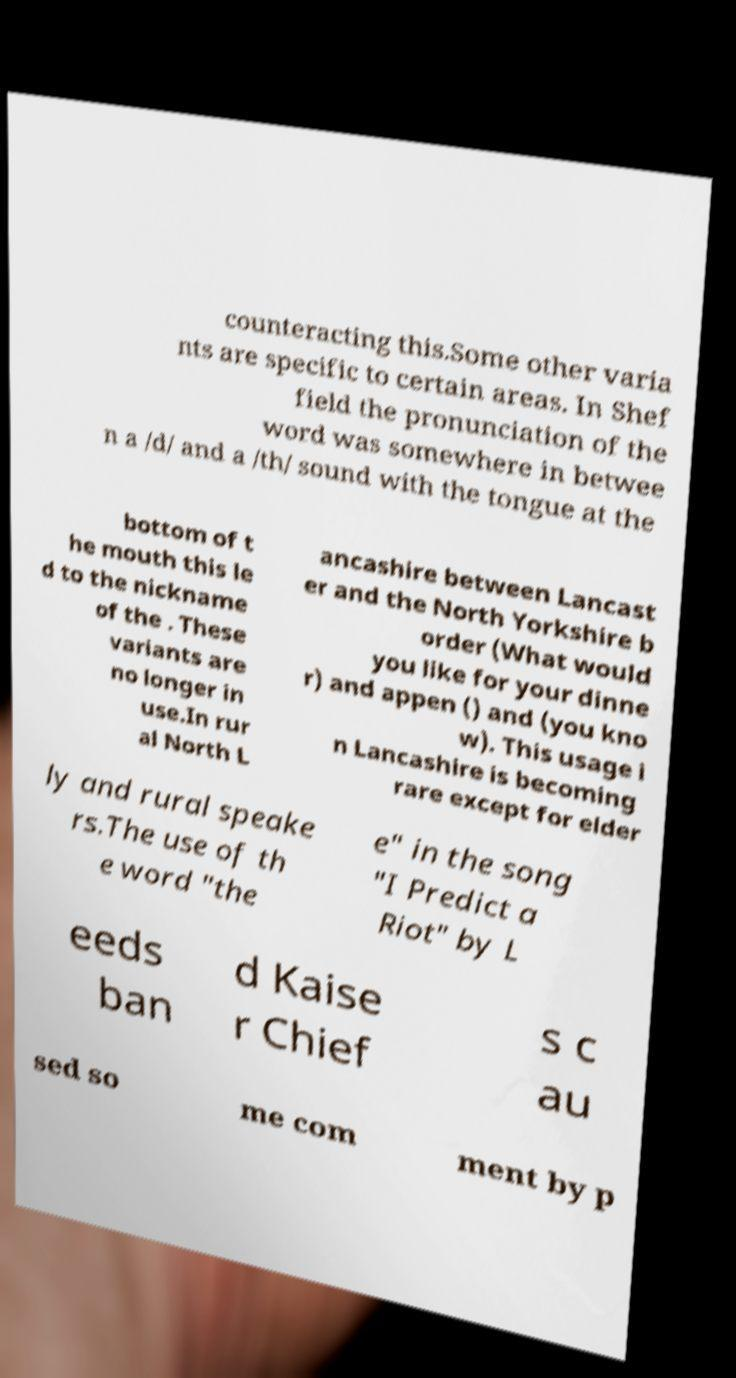For documentation purposes, I need the text within this image transcribed. Could you provide that? counteracting this.Some other varia nts are specific to certain areas. In Shef field the pronunciation of the word was somewhere in betwee n a /d/ and a /th/ sound with the tongue at the bottom of t he mouth this le d to the nickname of the . These variants are no longer in use.In rur al North L ancashire between Lancast er and the North Yorkshire b order (What would you like for your dinne r) and appen () and (you kno w). This usage i n Lancashire is becoming rare except for elder ly and rural speake rs.The use of th e word "the e" in the song "I Predict a Riot" by L eeds ban d Kaise r Chief s c au sed so me com ment by p 